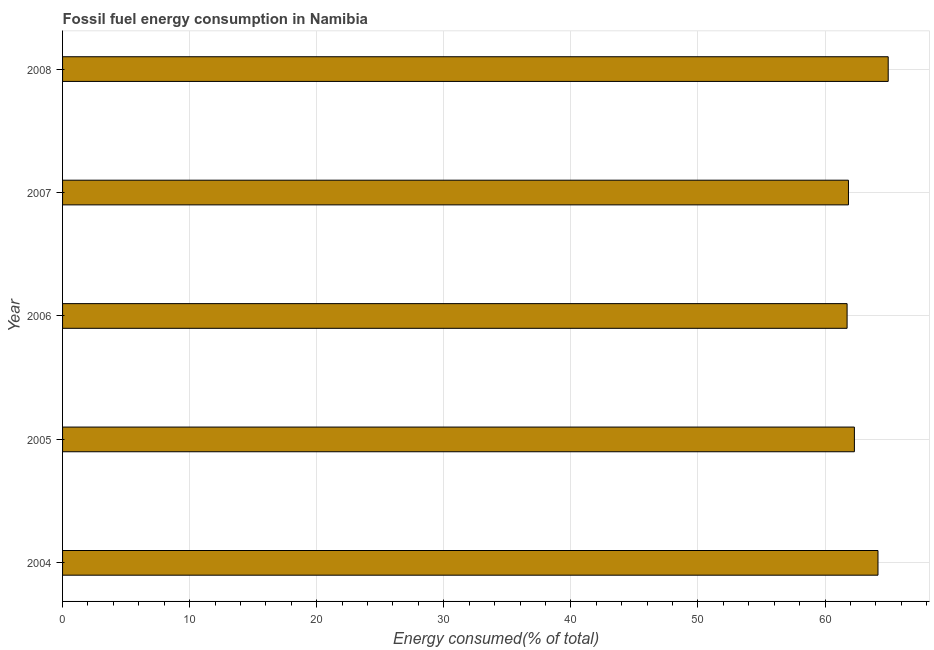What is the title of the graph?
Keep it short and to the point. Fossil fuel energy consumption in Namibia. What is the label or title of the X-axis?
Make the answer very short. Energy consumed(% of total). What is the fossil fuel energy consumption in 2004?
Provide a short and direct response. 64.17. Across all years, what is the maximum fossil fuel energy consumption?
Your answer should be very brief. 64.97. Across all years, what is the minimum fossil fuel energy consumption?
Your response must be concise. 61.74. What is the sum of the fossil fuel energy consumption?
Your answer should be very brief. 315.04. What is the difference between the fossil fuel energy consumption in 2004 and 2007?
Give a very brief answer. 2.32. What is the average fossil fuel energy consumption per year?
Provide a short and direct response. 63.01. What is the median fossil fuel energy consumption?
Provide a succinct answer. 62.31. Do a majority of the years between 2006 and 2007 (inclusive) have fossil fuel energy consumption greater than 18 %?
Ensure brevity in your answer.  Yes. What is the ratio of the fossil fuel energy consumption in 2004 to that in 2008?
Your answer should be very brief. 0.99. Is the difference between the fossil fuel energy consumption in 2007 and 2008 greater than the difference between any two years?
Provide a succinct answer. No. What is the difference between the highest and the second highest fossil fuel energy consumption?
Your response must be concise. 0.81. Is the sum of the fossil fuel energy consumption in 2006 and 2008 greater than the maximum fossil fuel energy consumption across all years?
Your response must be concise. Yes. What is the difference between the highest and the lowest fossil fuel energy consumption?
Provide a succinct answer. 3.24. How many bars are there?
Provide a succinct answer. 5. Are all the bars in the graph horizontal?
Your answer should be very brief. Yes. What is the difference between two consecutive major ticks on the X-axis?
Give a very brief answer. 10. Are the values on the major ticks of X-axis written in scientific E-notation?
Make the answer very short. No. What is the Energy consumed(% of total) in 2004?
Your answer should be very brief. 64.17. What is the Energy consumed(% of total) of 2005?
Your response must be concise. 62.31. What is the Energy consumed(% of total) in 2006?
Make the answer very short. 61.74. What is the Energy consumed(% of total) of 2007?
Your answer should be compact. 61.85. What is the Energy consumed(% of total) of 2008?
Your response must be concise. 64.97. What is the difference between the Energy consumed(% of total) in 2004 and 2005?
Offer a very short reply. 1.86. What is the difference between the Energy consumed(% of total) in 2004 and 2006?
Keep it short and to the point. 2.43. What is the difference between the Energy consumed(% of total) in 2004 and 2007?
Make the answer very short. 2.32. What is the difference between the Energy consumed(% of total) in 2004 and 2008?
Your response must be concise. -0.81. What is the difference between the Energy consumed(% of total) in 2005 and 2006?
Make the answer very short. 0.57. What is the difference between the Energy consumed(% of total) in 2005 and 2007?
Keep it short and to the point. 0.47. What is the difference between the Energy consumed(% of total) in 2005 and 2008?
Offer a very short reply. -2.66. What is the difference between the Energy consumed(% of total) in 2006 and 2007?
Make the answer very short. -0.11. What is the difference between the Energy consumed(% of total) in 2006 and 2008?
Provide a succinct answer. -3.24. What is the difference between the Energy consumed(% of total) in 2007 and 2008?
Ensure brevity in your answer.  -3.13. What is the ratio of the Energy consumed(% of total) in 2004 to that in 2006?
Ensure brevity in your answer.  1.04. What is the ratio of the Energy consumed(% of total) in 2004 to that in 2007?
Offer a very short reply. 1.04. What is the ratio of the Energy consumed(% of total) in 2004 to that in 2008?
Ensure brevity in your answer.  0.99. What is the ratio of the Energy consumed(% of total) in 2005 to that in 2007?
Your answer should be compact. 1.01. What is the ratio of the Energy consumed(% of total) in 2005 to that in 2008?
Provide a short and direct response. 0.96. What is the ratio of the Energy consumed(% of total) in 2006 to that in 2007?
Provide a succinct answer. 1. What is the ratio of the Energy consumed(% of total) in 2006 to that in 2008?
Offer a terse response. 0.95. What is the ratio of the Energy consumed(% of total) in 2007 to that in 2008?
Give a very brief answer. 0.95. 